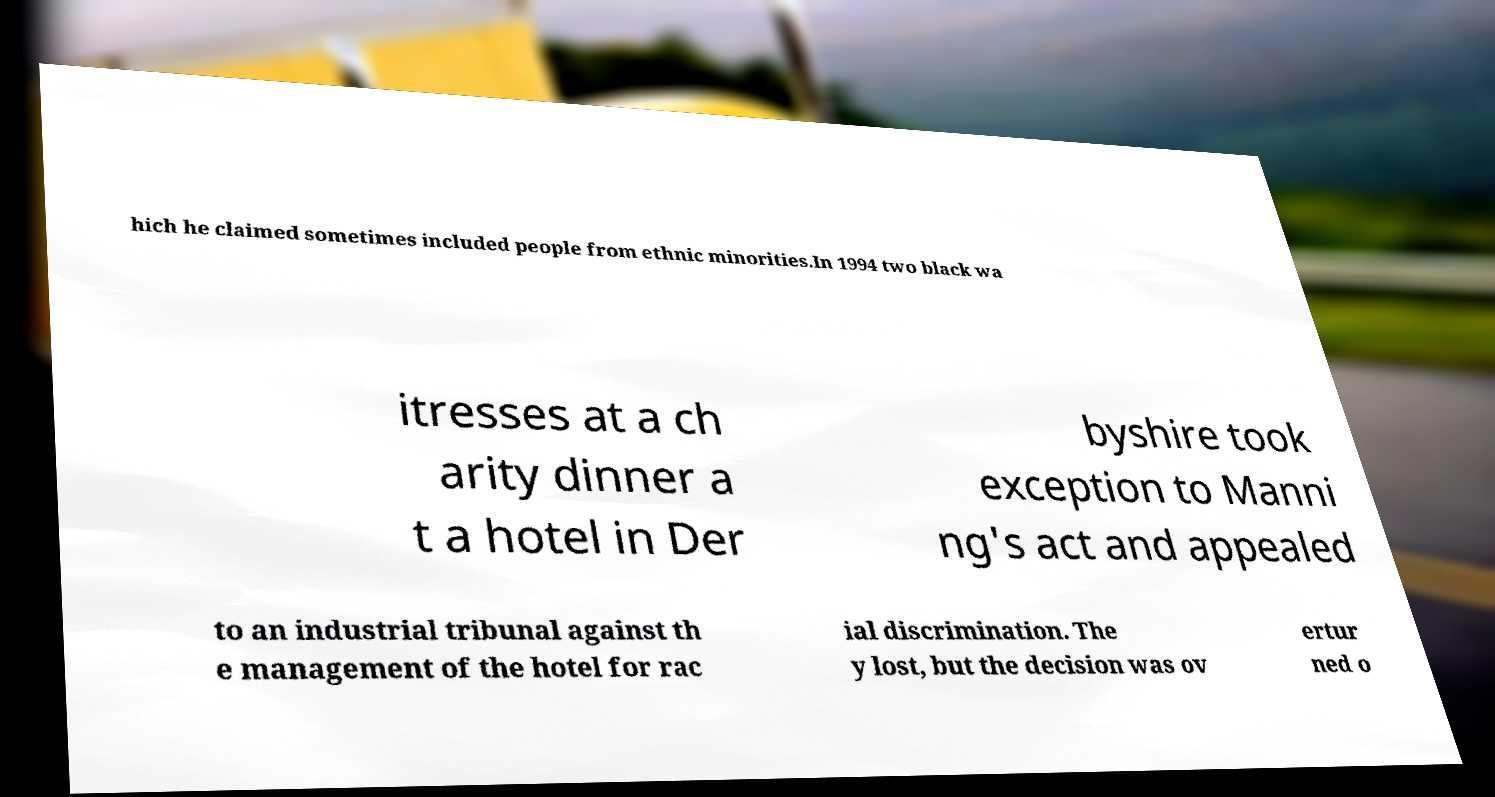For documentation purposes, I need the text within this image transcribed. Could you provide that? hich he claimed sometimes included people from ethnic minorities.In 1994 two black wa itresses at a ch arity dinner a t a hotel in Der byshire took exception to Manni ng's act and appealed to an industrial tribunal against th e management of the hotel for rac ial discrimination. The y lost, but the decision was ov ertur ned o 